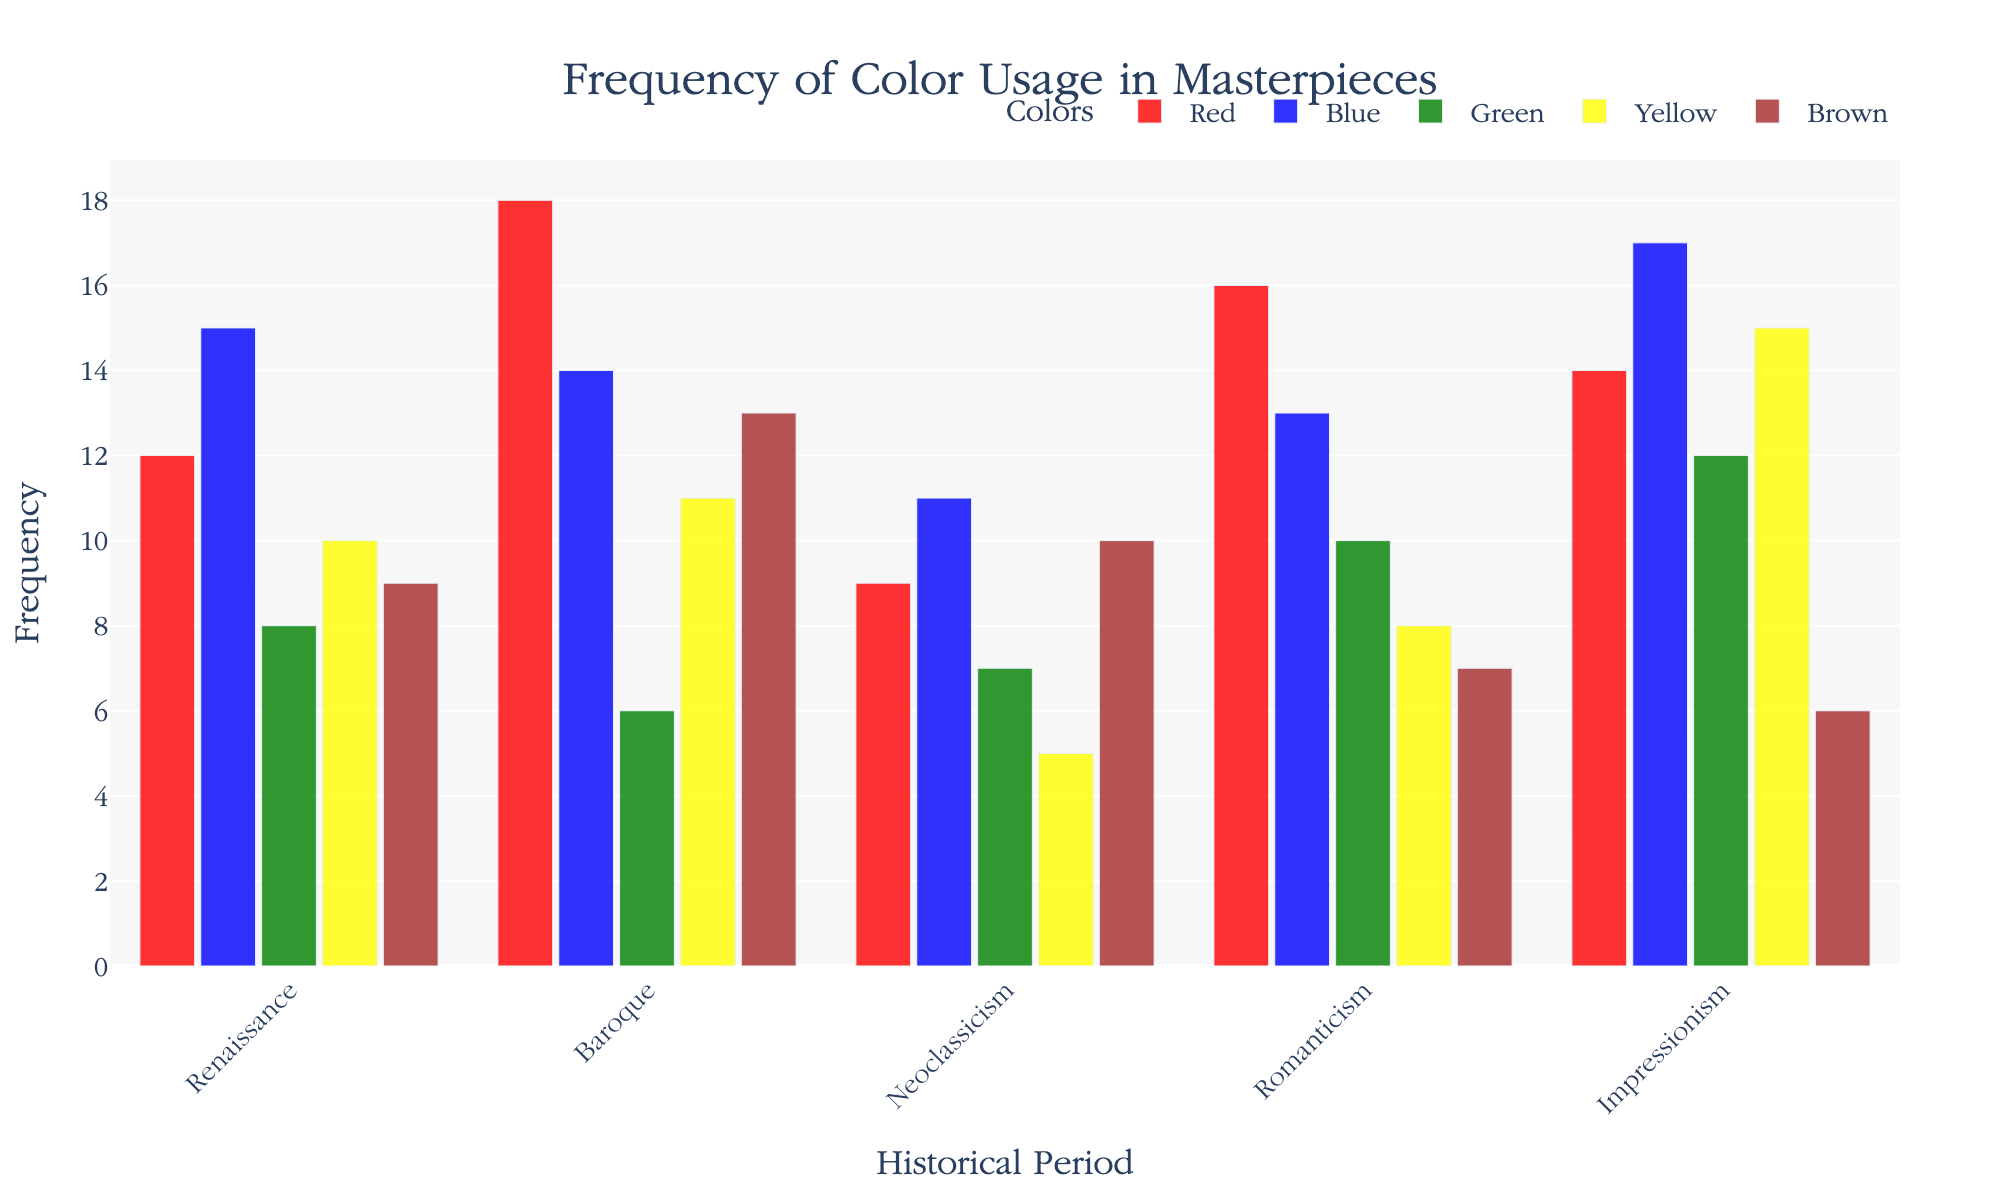What's the title of the chart? The title of the chart is located at the top center. It typically provides information about the contents or purpose of the chart. By looking at the top center, we see the text "Frequency of Color Usage in Masterpieces".
Answer: Frequency of Color Usage in Masterpieces What's the x-axis label of the chart? The x-axis label indicates what the x-axis represents. It is usually found below the x-axis. By examining the chart, we see that the label reads "Historical Period".
Answer: Historical Period How many periods are represented in the chart? We can count the number of unique labels on the x-axis to find how many periods are represented. By looking at the x-axis, we see labels for Renaissance, Baroque, Neoclassicism, Romanticism, and Impressionism.
Answer: 5 Which color has the highest usage frequency in the Baroque period? Locate the Baroque period on the x-axis, then compare the heights of the bars representing different colors. The highest bar represents the color with the highest usage frequency. For Baroque, the highest bar is red.
Answer: Red What's the total frequency of green usage across all periods? To find the total frequency, add the frequencies of green for each period: Renaissance (8), Baroque (6), Neoclassicism (7), Romanticism (10), and Impressionism (12). The sum is 8 + 6 + 7 + 10 + 12 = 43.
Answer: 43 Which period had the most frequent usage of blue? Find the period with the highest blue bar on the chart. By comparing the heights, we see that Impressionism has the highest blue bar with a frequency of 17.
Answer: Impressionism What is the average frequency of color usage for Renaissance? Add the frequencies of all colors for the Renaissance period and divide by the number of colors. The frequencies are Red (12), Blue (15), Green (8), Yellow (10), and Brown (9). The average is (12 + 15 + 8 + 10 + 9) / 5 = 54 / 5 = 10.8.
Answer: 10.8 Which colors have higher frequencies in Neoclassicism compared to Romanticism? Compare the frequency of each color in Neoclassicism and Romanticism. For each color, identify if the Neoclassicism frequency is greater. Red (9 < 16), Blue (11 < 13), Green (7 < 10), Yellow (5 < 8), Brown (10 > 7). Only Brown has a higher frequency in Neoclassicism.
Answer: Brown In which period does yellow have the lowest usage? Identify the lowest bar representing yellow across all periods. By comparing, we see that Neoclassicism has the lowest yellow bar with a frequency of 5.
Answer: Neoclassicism 